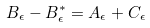Convert formula to latex. <formula><loc_0><loc_0><loc_500><loc_500>B _ { \epsilon } - B ^ { \ast } _ { \epsilon } = A _ { \epsilon } + C _ { \epsilon }</formula> 